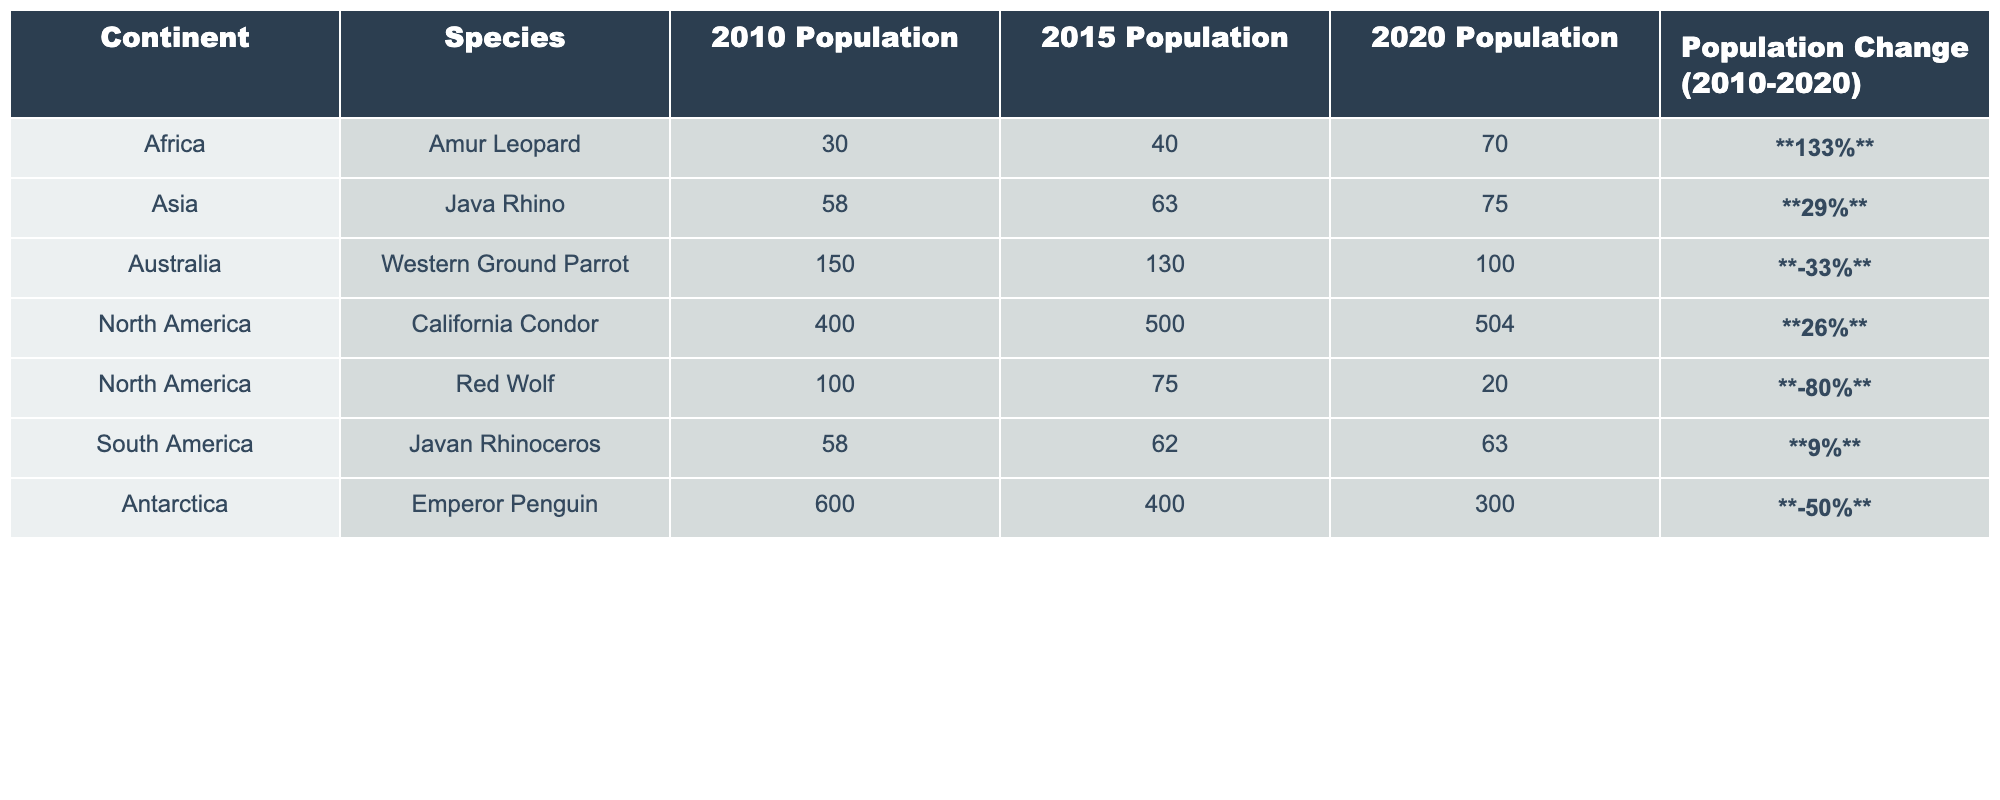What was the population of the Amur Leopard in 2020? According to the table, the population of the Amur Leopard in 2020 is listed as 70.
Answer: 70 Which species showed the highest percentage increase in population from 2010 to 2020? By comparing the "Population Change (2010-2020)" values, the Amur Leopard had the highest increase at 133%.
Answer: Amur Leopard What was the total population change for species in North America from 2010 to 2020? The California Condor's population changed by 104 (from 400 to 504) and the Red Wolf's population changed by -80 (from 100 to 20). The total change is 104 + (-80) = 24.
Answer: 24 Did any species outside of North America have a negative population trend from 2010 to 2020? Yes, species like the Western Ground Parrot and the Emperor Penguin both showed negative population trends, with decreases of 33% and 50% respectively.
Answer: Yes What was the average population of the Java Rhino over the three years? The populations for the Java Rhino were 58, 63, and 75 for 2010, 2015, and 2020 respectively. To find the average: (58 + 63 + 75) / 3 = 65.33.
Answer: 65.33 Which continent had the species with the highest population in 2010? The table indicates that the Emperor Penguin in Antarctica had the highest population in 2010 with 600 individuals.
Answer: Antarctica What is the percentage change of the Red Wolf population over the last decade? The Red Wolf's population decreased from 100 to 20, so the percentage change is calculated as ((20 - 100) / 100) * 100 = -80%.
Answer: -80% Is it true that all species listed in South America experienced a population increase? No, the Javan Rhinoceros experienced a minimal increase of 9%, not a significant one, and the only one listed. This statement is false as there may be other factors impacting species beyond these numbers.
Answer: No Which species saw a decrease in population but still maintained a positive percentage change from 2010 to 2020? No species with a decrease in raw numbers maintained a positive percentage change. All decreases in population resulted in negative percentage changes.
Answer: No Which species experienced the smallest population change over the last decade? The population of the Javan Rhinoceros changed by only 5 (from 58 to 63) which is the smallest absolute change compared to others.
Answer: Javan Rhinoceros 